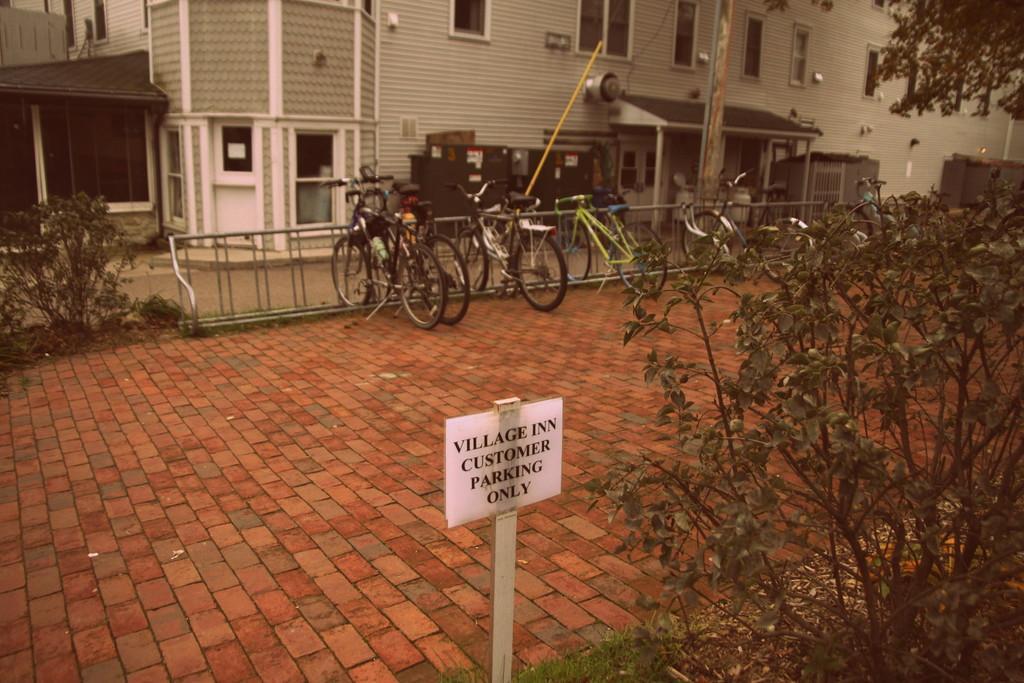Could you give a brief overview of what you see in this image? This image consists of the building at the top. There are bicycles in the middle. There are plants and trees on the right side and left side. 